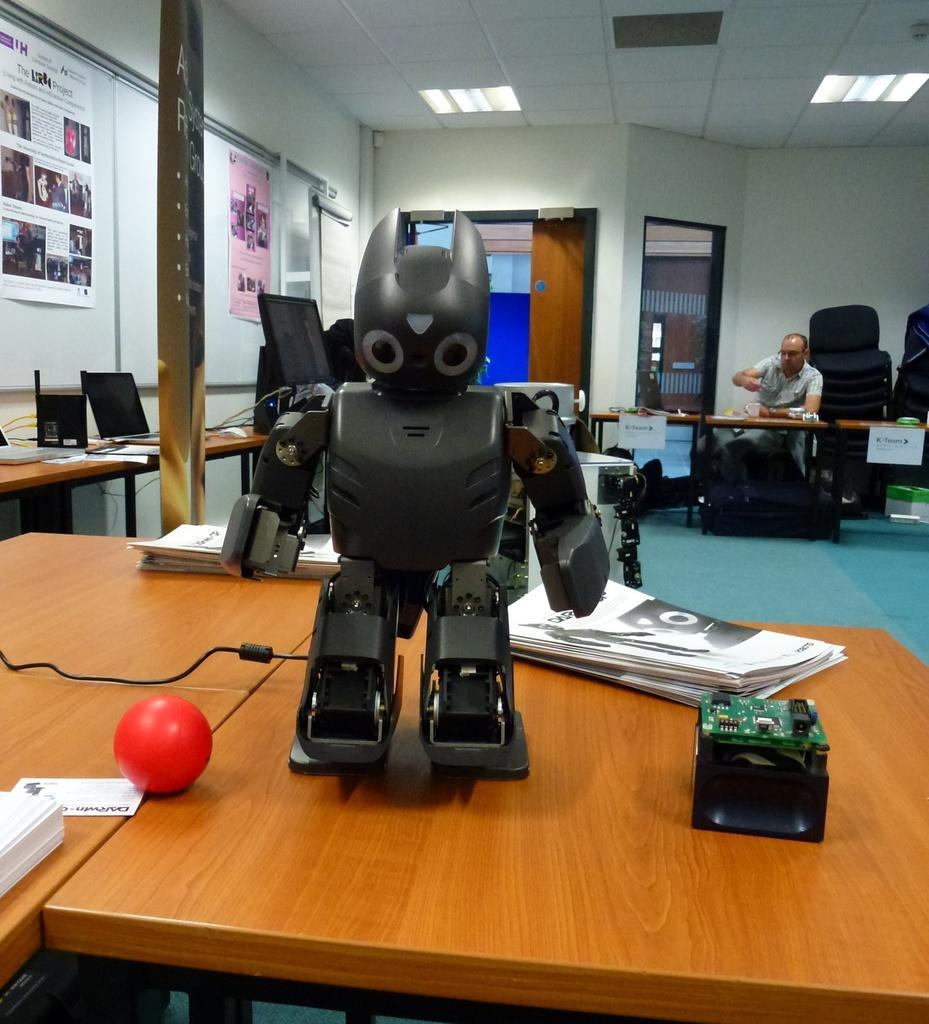How would you summarize this image in a sentence or two? In this image I can see a robot and papers on the table. In the back there is a person. To the left there are some papers attached to the wall. 